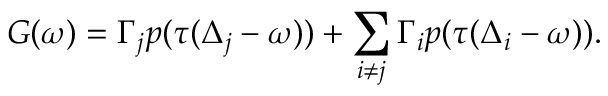<formula> <loc_0><loc_0><loc_500><loc_500>G ( \omega ) = \Gamma _ { j } p ( \tau ( \Delta _ { j } - \omega ) ) + \sum _ { i \neq j } \Gamma _ { i } p ( \tau ( \Delta _ { i } - \omega ) ) .</formula> 